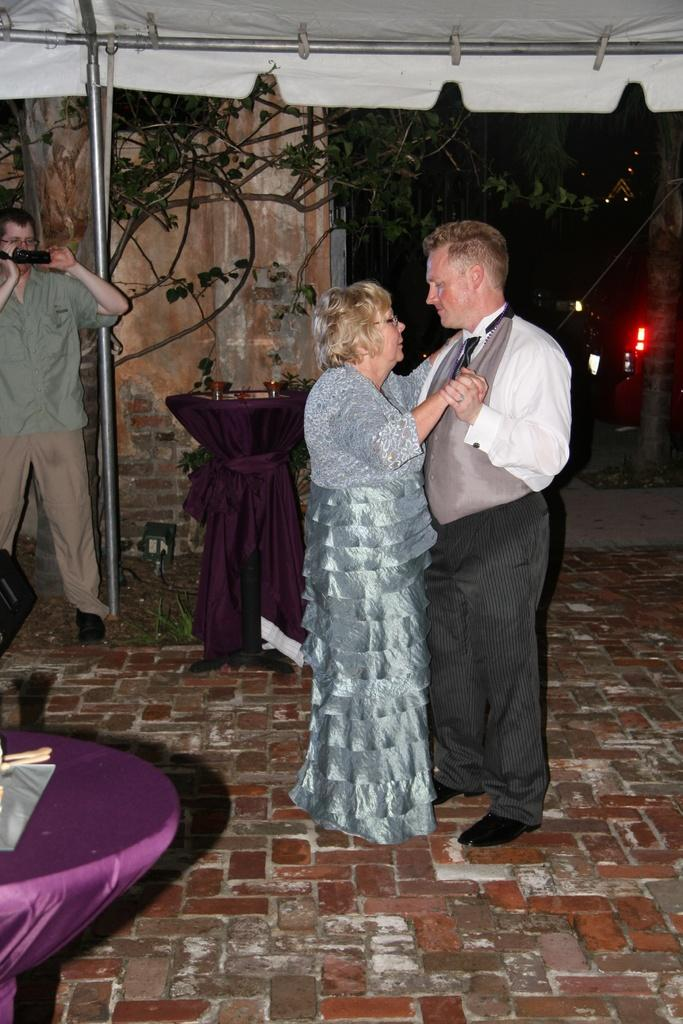What are the couple in the image doing? The couple is dancing in the image. Where are they dancing? They are under a tent. How many tables are visible in the image? There are two tables in the image. Who is holding a camera in the image? There is a person holding a camera in the image. What type of error can be seen in the image? There is no error present in the image. What kind of bulb is being used to light up the tent in the image? There is no mention of a bulb or lighting in the image; the tent is likely illuminated by natural light or the ambient light from the surroundings. 